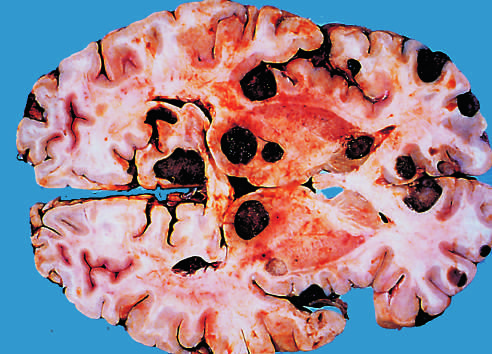s abscesses due to the presence of melanin?
Answer the question using a single word or phrase. No 